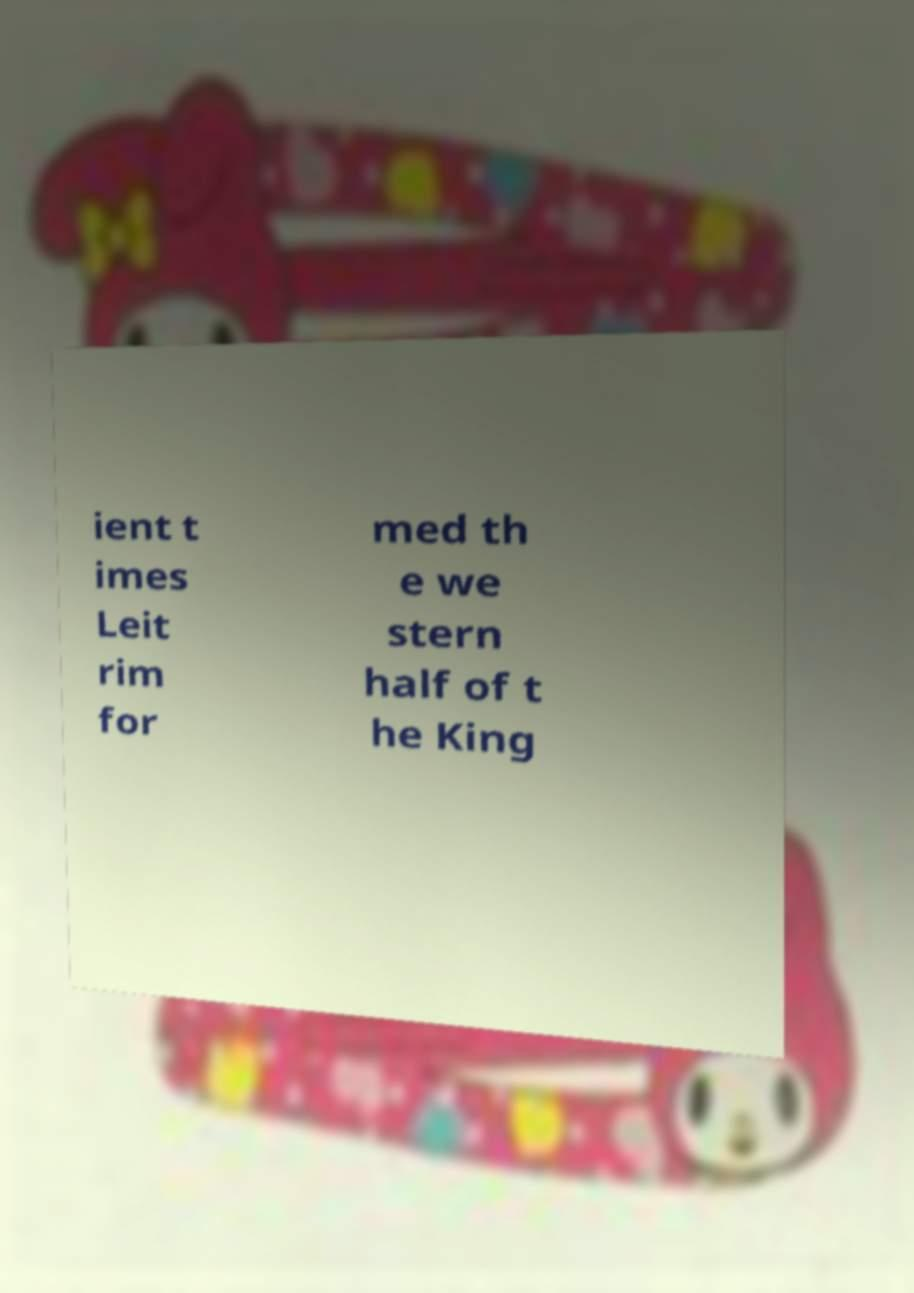Can you accurately transcribe the text from the provided image for me? ient t imes Leit rim for med th e we stern half of t he King 